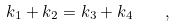Convert formula to latex. <formula><loc_0><loc_0><loc_500><loc_500>k _ { 1 } + k _ { 2 } = k _ { 3 } + k _ { 4 } \quad ,</formula> 